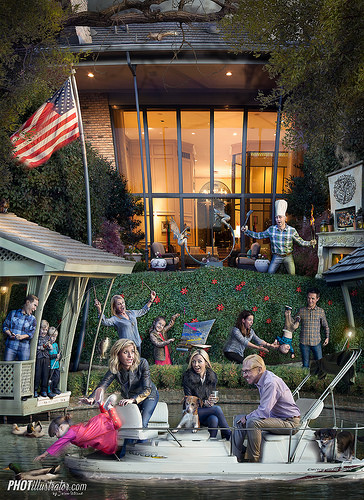<image>
Can you confirm if the pant leg is next to the flag? No. The pant leg is not positioned next to the flag. They are located in different areas of the scene. Is there a cook under the fireplace? No. The cook is not positioned under the fireplace. The vertical relationship between these objects is different. Is there a american flag on the dog? No. The american flag is not positioned on the dog. They may be near each other, but the american flag is not supported by or resting on top of the dog. 